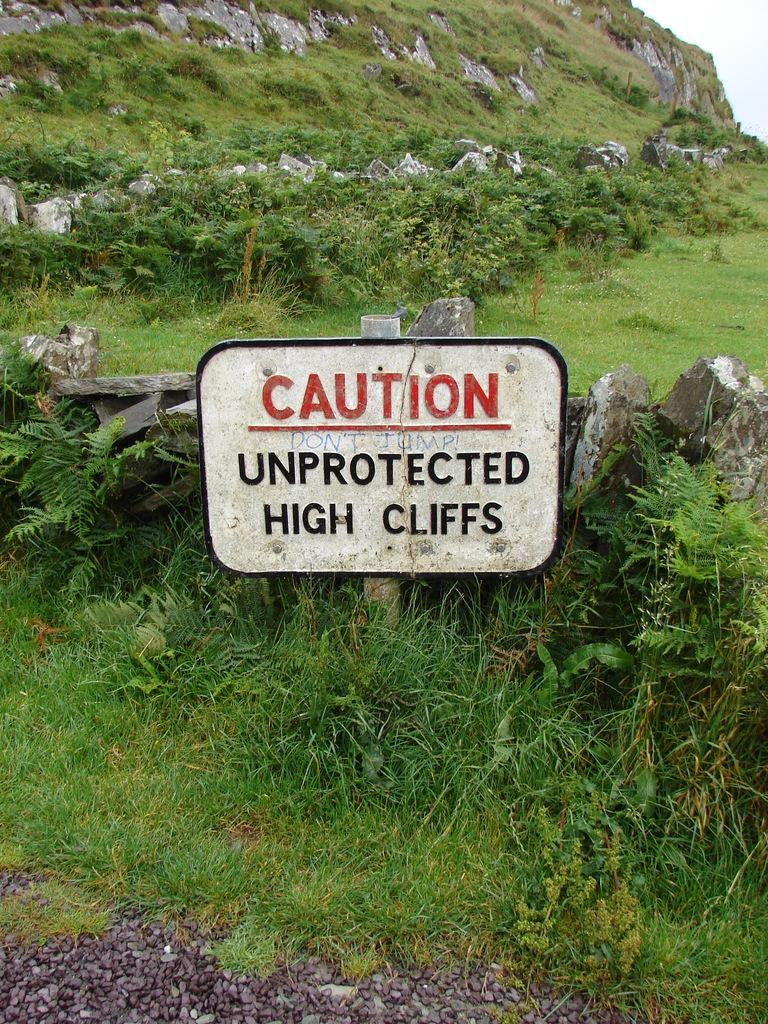What type of natural formation can be seen in the image? There is a mountain in the image. What type of vegetation is present in the image? Trees are present in the image. What type of geological feature can be seen in the image? Rocks are visible in the image. What type of ground cover is present in the image? There is green grass on the ground. What type of object with a white color can be seen in the image? There is a white-colored board in the image. What type of star can be seen shining brightly in the image? There is no star visible in the image; it features a mountain, trees, rocks, green grass, and a white-colored board. How much salt is present on the ground in the image? There is no salt present on the ground in the image; it features green grass. 